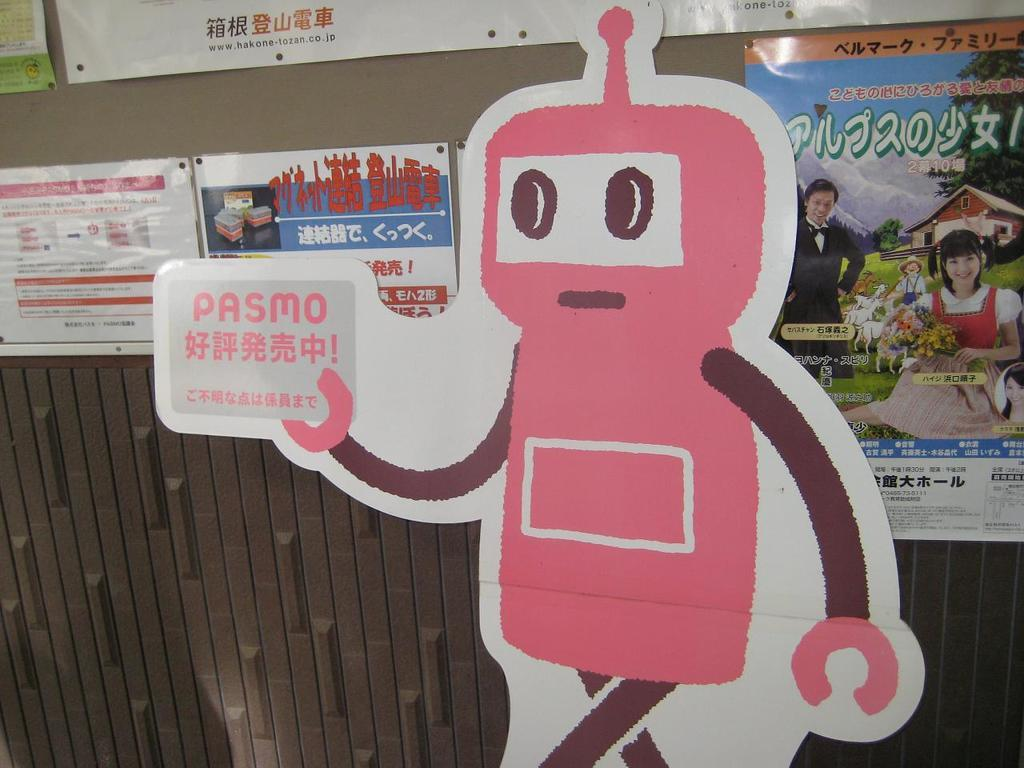What is the main structure visible in the image? There is a wall in the image. What is attached to the wall? There are posters pasted on the wall. How does the wall measure the distance between two points in the image? The wall does not measure the distance between two points in the image; it is a stationary structure with posters pasted on it. 